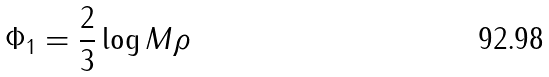<formula> <loc_0><loc_0><loc_500><loc_500>\Phi _ { 1 } = \frac { 2 } { 3 } \log M \rho</formula> 